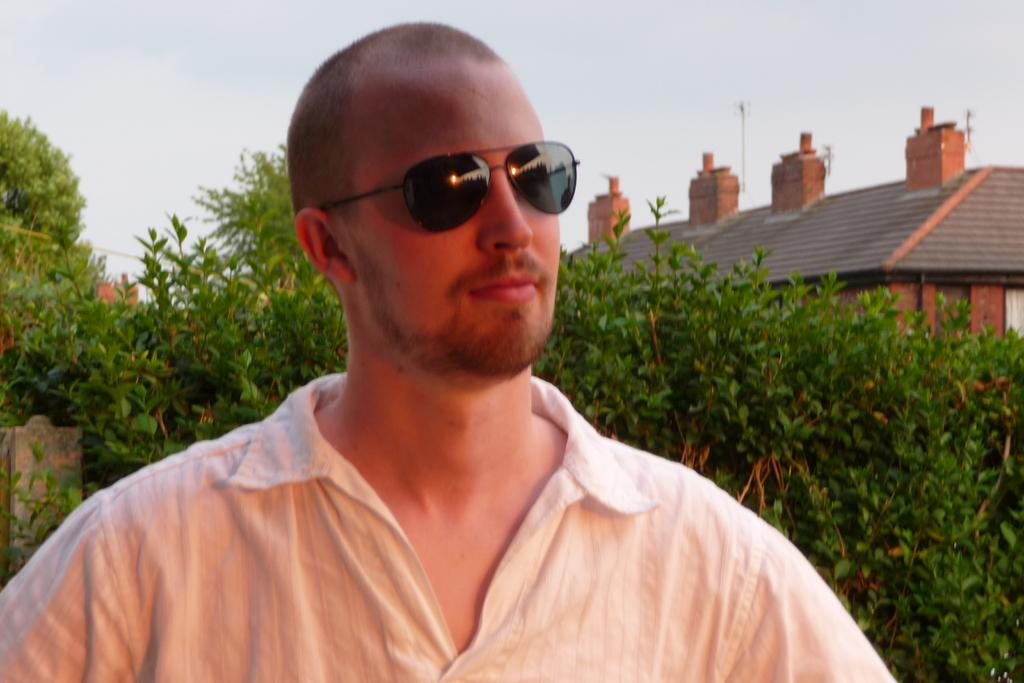What type of natural elements can be seen in the image? There are trees in the image. What type of man-made structures are present in the image? There are buildings in the image. Can you describe the man in the image? The man is standing in the image and is wearing sunglasses. How would you describe the weather in the image? The sky is cloudy in the image. What is the man's reaction to the sudden change in the route in the image? There is no information about a route or a sudden change in the image, and the man's reaction cannot be determined. What part of the man's body is visible in the image? The provided facts do not specify which part of the man's body is visible in the image. 